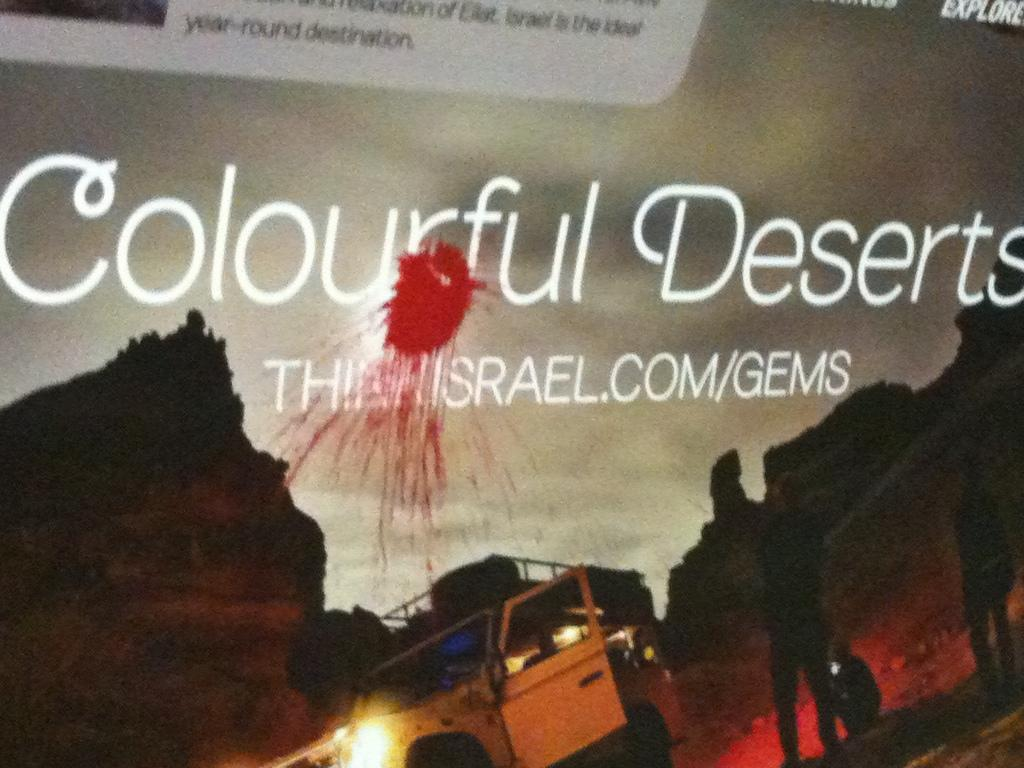<image>
Give a short and clear explanation of the subsequent image. A poster has the word Colourful Deserts on it above an internet address. 